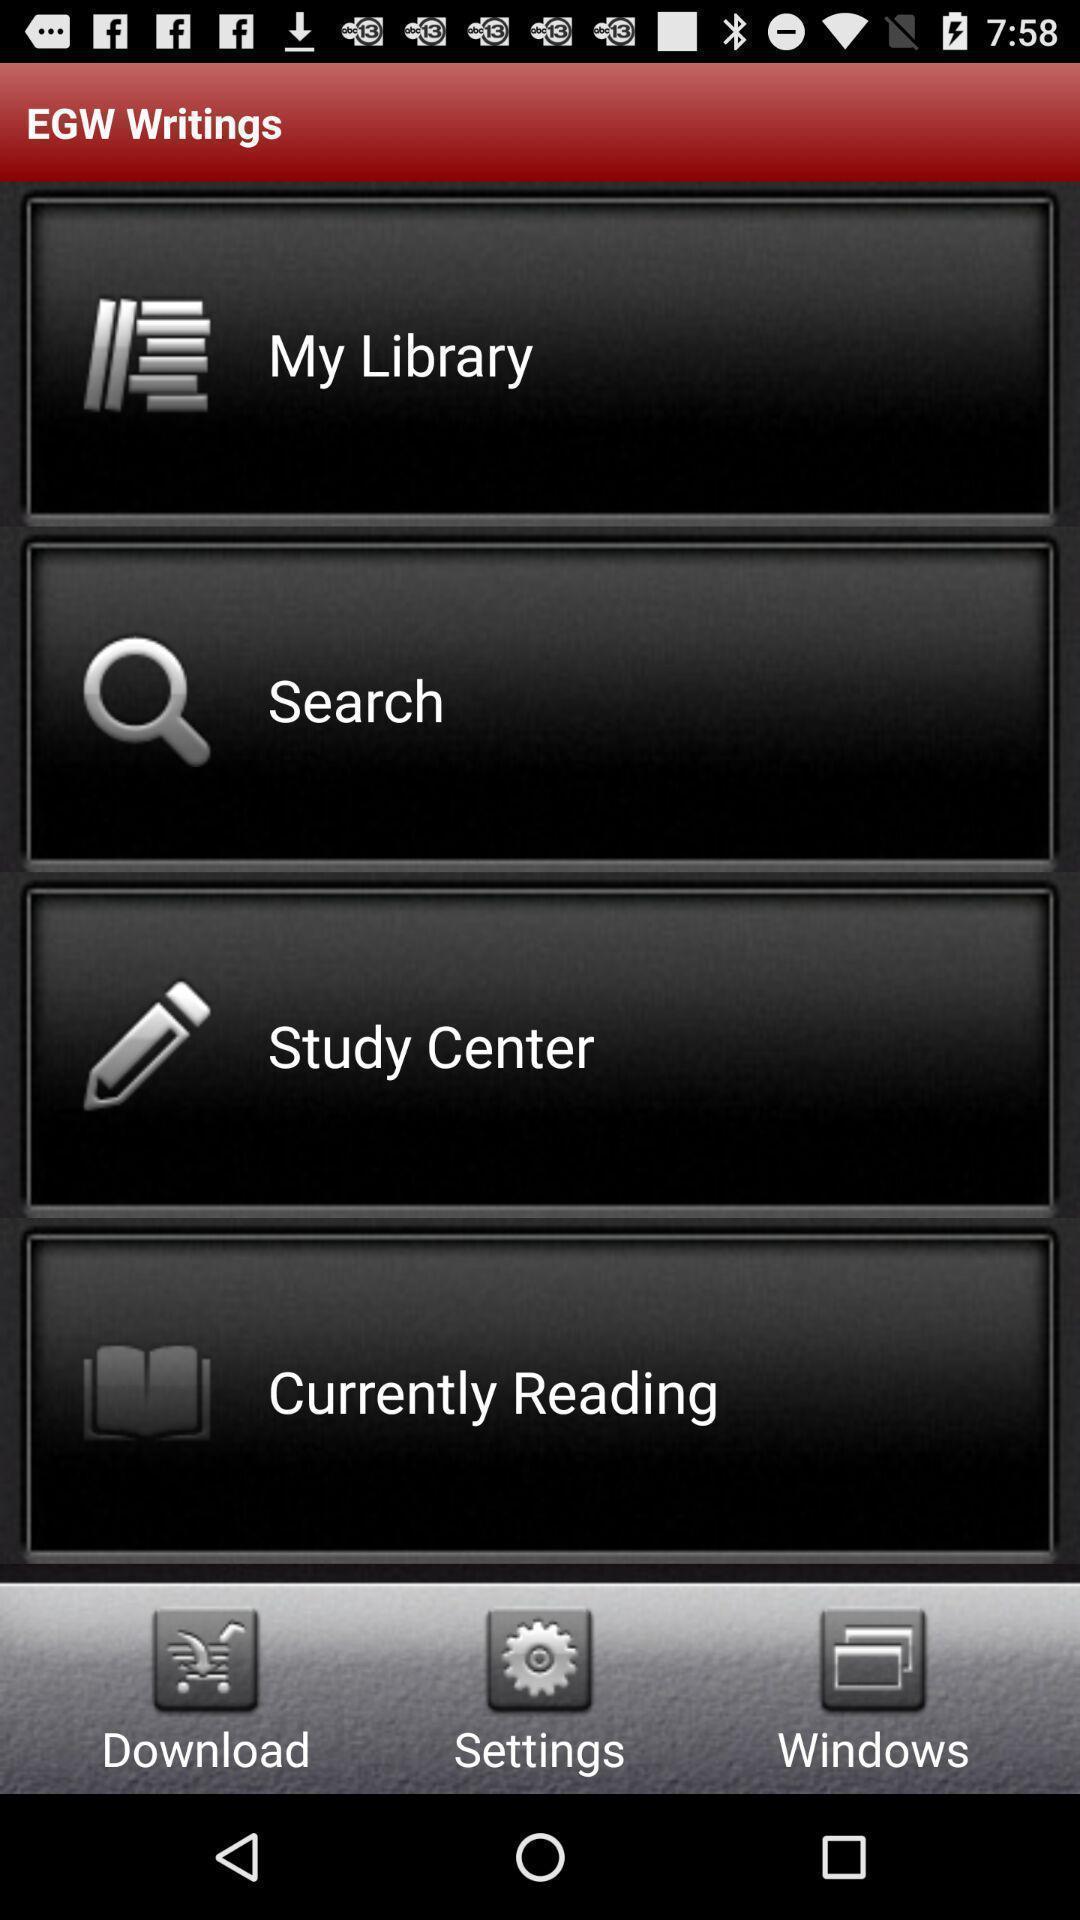Please provide a description for this image. Page showing the options in writings app. 